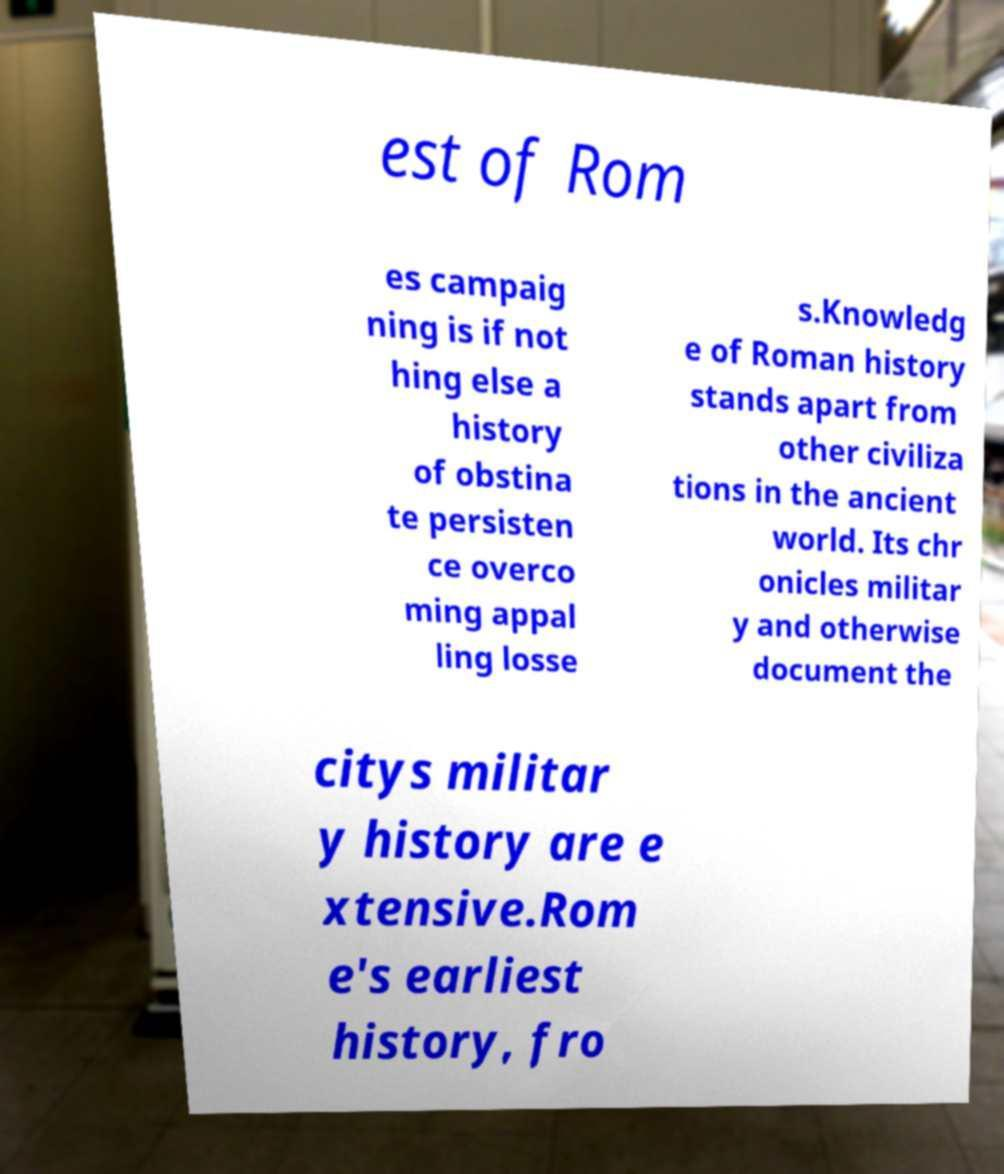For documentation purposes, I need the text within this image transcribed. Could you provide that? est of Rom es campaig ning is if not hing else a history of obstina te persisten ce overco ming appal ling losse s.Knowledg e of Roman history stands apart from other civiliza tions in the ancient world. Its chr onicles militar y and otherwise document the citys militar y history are e xtensive.Rom e's earliest history, fro 